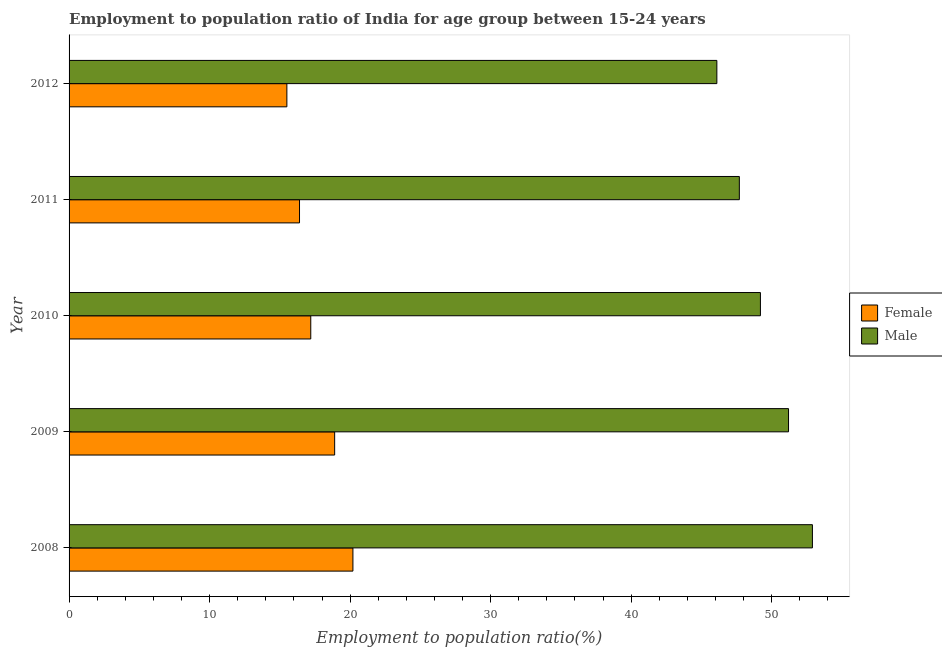How many different coloured bars are there?
Keep it short and to the point. 2. How many groups of bars are there?
Make the answer very short. 5. Are the number of bars on each tick of the Y-axis equal?
Provide a short and direct response. Yes. How many bars are there on the 3rd tick from the top?
Ensure brevity in your answer.  2. How many bars are there on the 2nd tick from the bottom?
Make the answer very short. 2. What is the label of the 3rd group of bars from the top?
Offer a very short reply. 2010. What is the employment to population ratio(male) in 2009?
Keep it short and to the point. 51.2. Across all years, what is the maximum employment to population ratio(female)?
Your answer should be compact. 20.2. Across all years, what is the minimum employment to population ratio(female)?
Your answer should be compact. 15.5. In which year was the employment to population ratio(female) maximum?
Provide a short and direct response. 2008. What is the total employment to population ratio(female) in the graph?
Provide a succinct answer. 88.2. What is the difference between the employment to population ratio(male) in 2008 and that in 2012?
Your response must be concise. 6.8. What is the difference between the employment to population ratio(female) in 2009 and the employment to population ratio(male) in 2008?
Keep it short and to the point. -34. What is the average employment to population ratio(male) per year?
Keep it short and to the point. 49.42. In the year 2009, what is the difference between the employment to population ratio(male) and employment to population ratio(female)?
Your answer should be very brief. 32.3. What is the ratio of the employment to population ratio(male) in 2009 to that in 2010?
Your response must be concise. 1.04. Is the employment to population ratio(female) in 2011 less than that in 2012?
Your response must be concise. No. Is the difference between the employment to population ratio(male) in 2009 and 2010 greater than the difference between the employment to population ratio(female) in 2009 and 2010?
Give a very brief answer. Yes. What is the difference between the highest and the second highest employment to population ratio(male)?
Offer a very short reply. 1.7. What is the difference between the highest and the lowest employment to population ratio(male)?
Your response must be concise. 6.8. Is the sum of the employment to population ratio(male) in 2008 and 2012 greater than the maximum employment to population ratio(female) across all years?
Make the answer very short. Yes. What does the 2nd bar from the bottom in 2009 represents?
Provide a succinct answer. Male. Does the graph contain any zero values?
Provide a short and direct response. No. How many legend labels are there?
Give a very brief answer. 2. What is the title of the graph?
Offer a terse response. Employment to population ratio of India for age group between 15-24 years. Does "Non-solid fuel" appear as one of the legend labels in the graph?
Offer a very short reply. No. What is the Employment to population ratio(%) in Female in 2008?
Make the answer very short. 20.2. What is the Employment to population ratio(%) of Male in 2008?
Offer a terse response. 52.9. What is the Employment to population ratio(%) of Female in 2009?
Your answer should be very brief. 18.9. What is the Employment to population ratio(%) of Male in 2009?
Provide a short and direct response. 51.2. What is the Employment to population ratio(%) of Female in 2010?
Your answer should be compact. 17.2. What is the Employment to population ratio(%) of Male in 2010?
Your answer should be very brief. 49.2. What is the Employment to population ratio(%) of Female in 2011?
Offer a terse response. 16.4. What is the Employment to population ratio(%) in Male in 2011?
Make the answer very short. 47.7. What is the Employment to population ratio(%) of Female in 2012?
Give a very brief answer. 15.5. What is the Employment to population ratio(%) in Male in 2012?
Provide a succinct answer. 46.1. Across all years, what is the maximum Employment to population ratio(%) in Female?
Make the answer very short. 20.2. Across all years, what is the maximum Employment to population ratio(%) in Male?
Make the answer very short. 52.9. Across all years, what is the minimum Employment to population ratio(%) in Female?
Offer a very short reply. 15.5. Across all years, what is the minimum Employment to population ratio(%) of Male?
Keep it short and to the point. 46.1. What is the total Employment to population ratio(%) of Female in the graph?
Provide a short and direct response. 88.2. What is the total Employment to population ratio(%) in Male in the graph?
Offer a very short reply. 247.1. What is the difference between the Employment to population ratio(%) in Female in 2008 and that in 2009?
Your response must be concise. 1.3. What is the difference between the Employment to population ratio(%) of Female in 2008 and that in 2010?
Provide a succinct answer. 3. What is the difference between the Employment to population ratio(%) in Male in 2008 and that in 2010?
Ensure brevity in your answer.  3.7. What is the difference between the Employment to population ratio(%) in Female in 2008 and that in 2012?
Offer a terse response. 4.7. What is the difference between the Employment to population ratio(%) of Male in 2008 and that in 2012?
Ensure brevity in your answer.  6.8. What is the difference between the Employment to population ratio(%) in Female in 2009 and that in 2010?
Provide a succinct answer. 1.7. What is the difference between the Employment to population ratio(%) of Male in 2009 and that in 2010?
Offer a terse response. 2. What is the difference between the Employment to population ratio(%) in Female in 2009 and that in 2011?
Offer a very short reply. 2.5. What is the difference between the Employment to population ratio(%) in Male in 2009 and that in 2012?
Ensure brevity in your answer.  5.1. What is the difference between the Employment to population ratio(%) of Female in 2010 and that in 2011?
Your answer should be very brief. 0.8. What is the difference between the Employment to population ratio(%) in Male in 2010 and that in 2012?
Offer a very short reply. 3.1. What is the difference between the Employment to population ratio(%) of Male in 2011 and that in 2012?
Provide a short and direct response. 1.6. What is the difference between the Employment to population ratio(%) in Female in 2008 and the Employment to population ratio(%) in Male in 2009?
Make the answer very short. -31. What is the difference between the Employment to population ratio(%) in Female in 2008 and the Employment to population ratio(%) in Male in 2011?
Your answer should be very brief. -27.5. What is the difference between the Employment to population ratio(%) of Female in 2008 and the Employment to population ratio(%) of Male in 2012?
Give a very brief answer. -25.9. What is the difference between the Employment to population ratio(%) in Female in 2009 and the Employment to population ratio(%) in Male in 2010?
Your answer should be very brief. -30.3. What is the difference between the Employment to population ratio(%) in Female in 2009 and the Employment to population ratio(%) in Male in 2011?
Keep it short and to the point. -28.8. What is the difference between the Employment to population ratio(%) of Female in 2009 and the Employment to population ratio(%) of Male in 2012?
Make the answer very short. -27.2. What is the difference between the Employment to population ratio(%) in Female in 2010 and the Employment to population ratio(%) in Male in 2011?
Provide a succinct answer. -30.5. What is the difference between the Employment to population ratio(%) in Female in 2010 and the Employment to population ratio(%) in Male in 2012?
Your response must be concise. -28.9. What is the difference between the Employment to population ratio(%) in Female in 2011 and the Employment to population ratio(%) in Male in 2012?
Provide a succinct answer. -29.7. What is the average Employment to population ratio(%) in Female per year?
Your response must be concise. 17.64. What is the average Employment to population ratio(%) of Male per year?
Ensure brevity in your answer.  49.42. In the year 2008, what is the difference between the Employment to population ratio(%) of Female and Employment to population ratio(%) of Male?
Your answer should be very brief. -32.7. In the year 2009, what is the difference between the Employment to population ratio(%) of Female and Employment to population ratio(%) of Male?
Offer a very short reply. -32.3. In the year 2010, what is the difference between the Employment to population ratio(%) in Female and Employment to population ratio(%) in Male?
Offer a very short reply. -32. In the year 2011, what is the difference between the Employment to population ratio(%) of Female and Employment to population ratio(%) of Male?
Keep it short and to the point. -31.3. In the year 2012, what is the difference between the Employment to population ratio(%) of Female and Employment to population ratio(%) of Male?
Keep it short and to the point. -30.6. What is the ratio of the Employment to population ratio(%) in Female in 2008 to that in 2009?
Give a very brief answer. 1.07. What is the ratio of the Employment to population ratio(%) of Male in 2008 to that in 2009?
Your answer should be very brief. 1.03. What is the ratio of the Employment to population ratio(%) of Female in 2008 to that in 2010?
Your answer should be compact. 1.17. What is the ratio of the Employment to population ratio(%) in Male in 2008 to that in 2010?
Give a very brief answer. 1.08. What is the ratio of the Employment to population ratio(%) in Female in 2008 to that in 2011?
Your answer should be very brief. 1.23. What is the ratio of the Employment to population ratio(%) in Male in 2008 to that in 2011?
Offer a very short reply. 1.11. What is the ratio of the Employment to population ratio(%) in Female in 2008 to that in 2012?
Provide a succinct answer. 1.3. What is the ratio of the Employment to population ratio(%) in Male in 2008 to that in 2012?
Make the answer very short. 1.15. What is the ratio of the Employment to population ratio(%) in Female in 2009 to that in 2010?
Offer a terse response. 1.1. What is the ratio of the Employment to population ratio(%) of Male in 2009 to that in 2010?
Provide a short and direct response. 1.04. What is the ratio of the Employment to population ratio(%) in Female in 2009 to that in 2011?
Your answer should be compact. 1.15. What is the ratio of the Employment to population ratio(%) in Male in 2009 to that in 2011?
Make the answer very short. 1.07. What is the ratio of the Employment to population ratio(%) of Female in 2009 to that in 2012?
Provide a short and direct response. 1.22. What is the ratio of the Employment to population ratio(%) in Male in 2009 to that in 2012?
Give a very brief answer. 1.11. What is the ratio of the Employment to population ratio(%) in Female in 2010 to that in 2011?
Provide a succinct answer. 1.05. What is the ratio of the Employment to population ratio(%) of Male in 2010 to that in 2011?
Your answer should be very brief. 1.03. What is the ratio of the Employment to population ratio(%) in Female in 2010 to that in 2012?
Keep it short and to the point. 1.11. What is the ratio of the Employment to population ratio(%) of Male in 2010 to that in 2012?
Give a very brief answer. 1.07. What is the ratio of the Employment to population ratio(%) in Female in 2011 to that in 2012?
Keep it short and to the point. 1.06. What is the ratio of the Employment to population ratio(%) of Male in 2011 to that in 2012?
Your response must be concise. 1.03. What is the difference between the highest and the second highest Employment to population ratio(%) of Female?
Make the answer very short. 1.3. What is the difference between the highest and the lowest Employment to population ratio(%) of Male?
Your answer should be very brief. 6.8. 